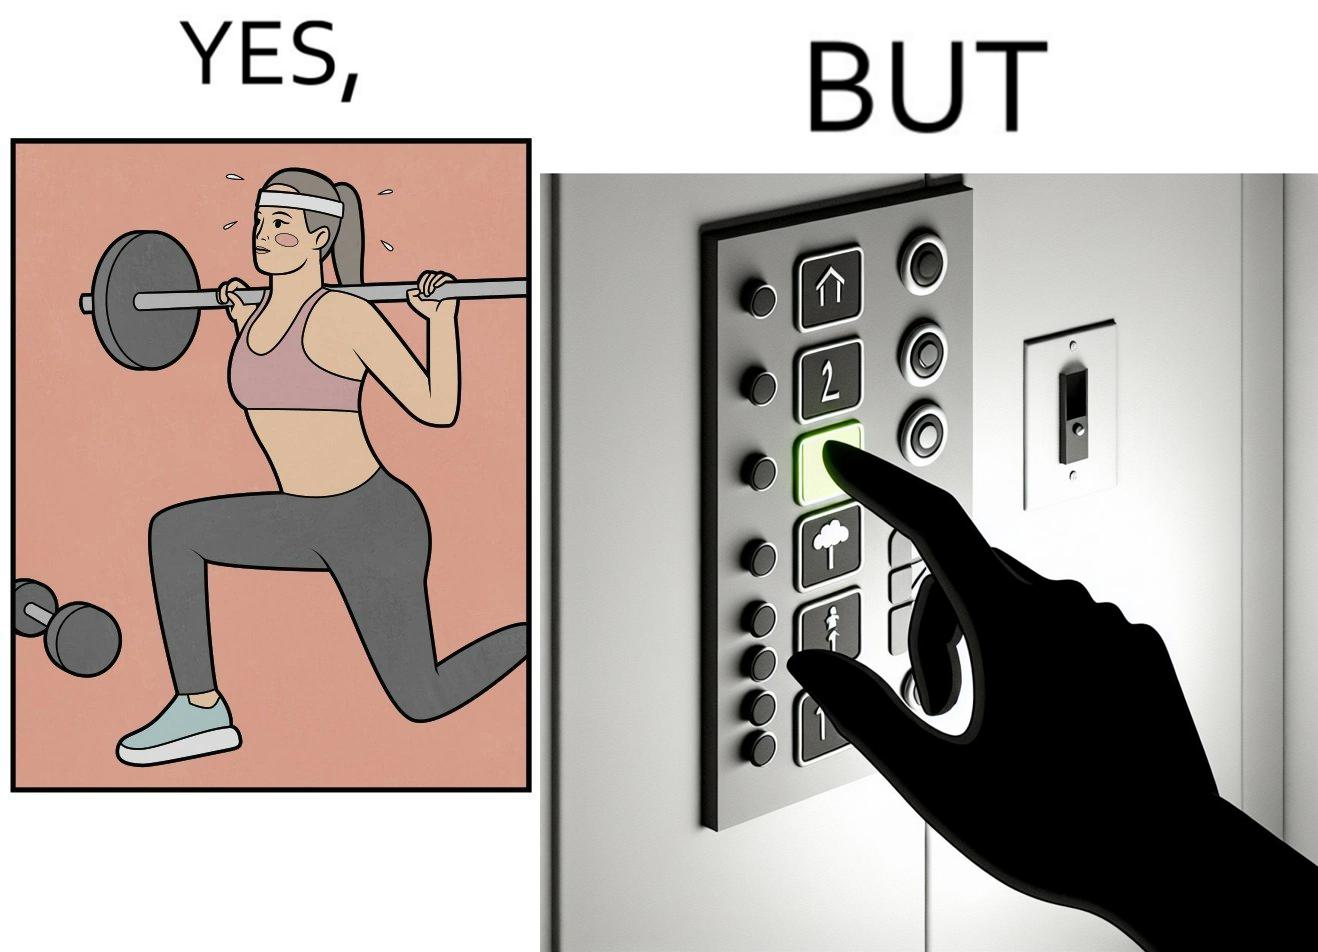What is shown in this image? The image is satirical because it shows that while people do various kinds of exercises and go to gym to stay fit, they avoid doing simplest of physical tasks like using stairs instead of elevators to get to even the first or the second floor of a building. 